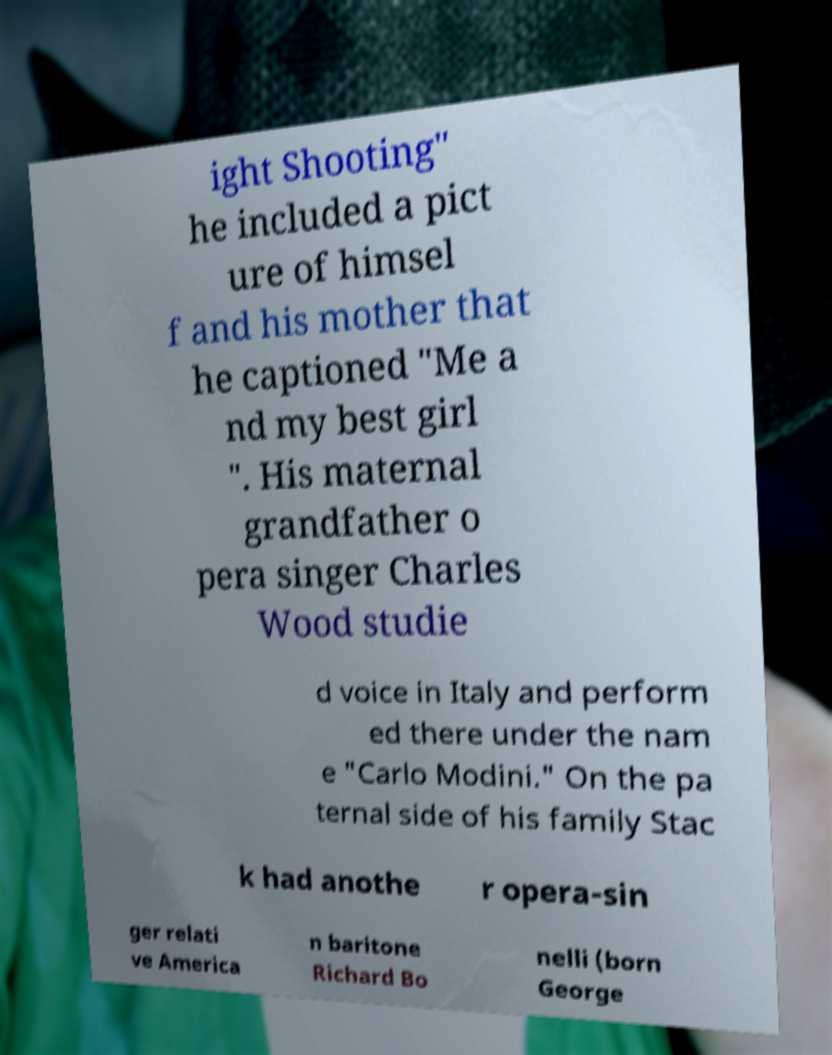Can you accurately transcribe the text from the provided image for me? ight Shooting" he included a pict ure of himsel f and his mother that he captioned "Me a nd my best girl ". His maternal grandfather o pera singer Charles Wood studie d voice in Italy and perform ed there under the nam e "Carlo Modini." On the pa ternal side of his family Stac k had anothe r opera-sin ger relati ve America n baritone Richard Bo nelli (born George 